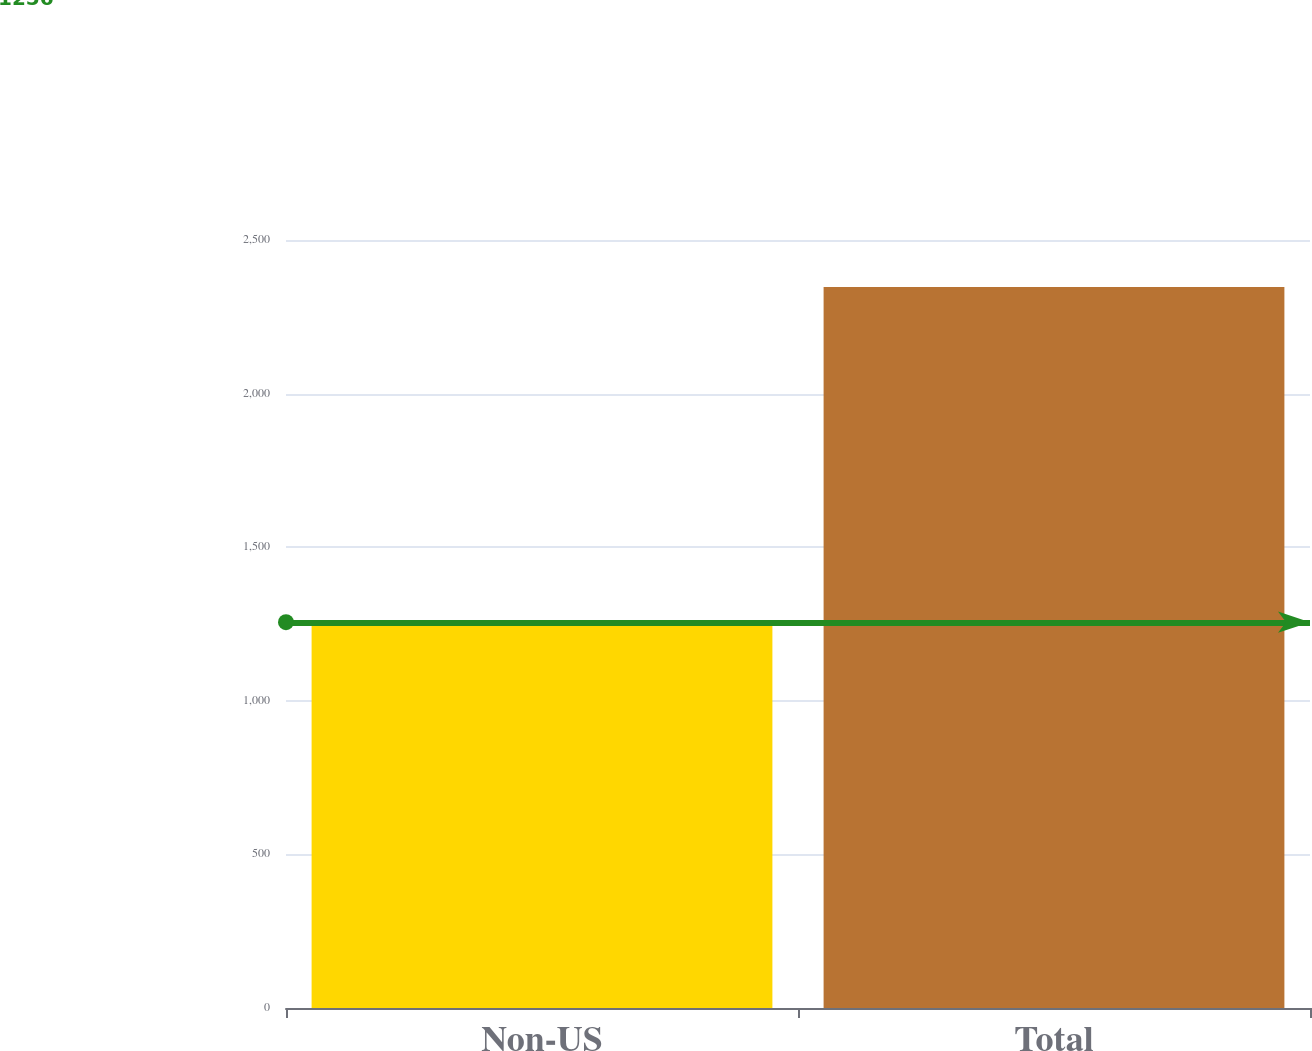Convert chart to OTSL. <chart><loc_0><loc_0><loc_500><loc_500><bar_chart><fcel>Non-US<fcel>Total<nl><fcel>1256<fcel>2347<nl></chart> 